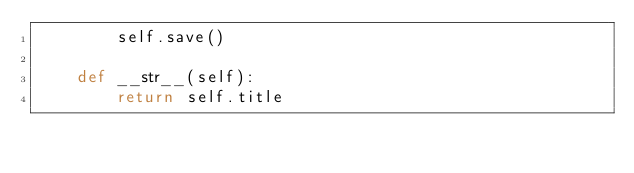Convert code to text. <code><loc_0><loc_0><loc_500><loc_500><_Python_>        self.save()

    def __str__(self):
        return self.title</code> 